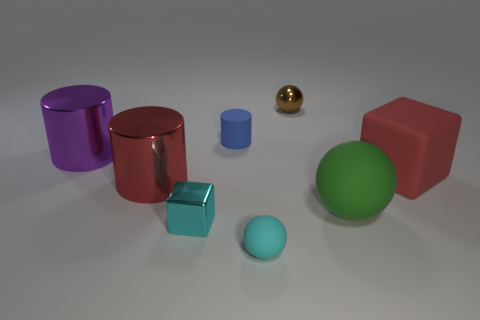There is a ball behind the purple cylinder; is it the same color as the matte cube?
Provide a short and direct response. No. What size is the purple metal object that is the same shape as the tiny blue rubber object?
Provide a succinct answer. Large. How many things are big objects to the right of the blue matte cylinder or tiny shiny objects behind the purple cylinder?
Provide a short and direct response. 3. What shape is the red object on the left side of the tiny object behind the small blue matte cylinder?
Make the answer very short. Cylinder. Are there any other things that are the same color as the small matte cylinder?
Your answer should be compact. No. Are there any other things that are the same size as the blue matte cylinder?
Offer a terse response. Yes. How many things are small red cylinders or large cylinders?
Keep it short and to the point. 2. Is there a purple metallic object that has the same size as the cyan matte thing?
Provide a short and direct response. No. The large red metallic object has what shape?
Make the answer very short. Cylinder. Are there more blue rubber cylinders in front of the brown metallic sphere than metal objects that are left of the small blue matte cylinder?
Provide a succinct answer. No. 